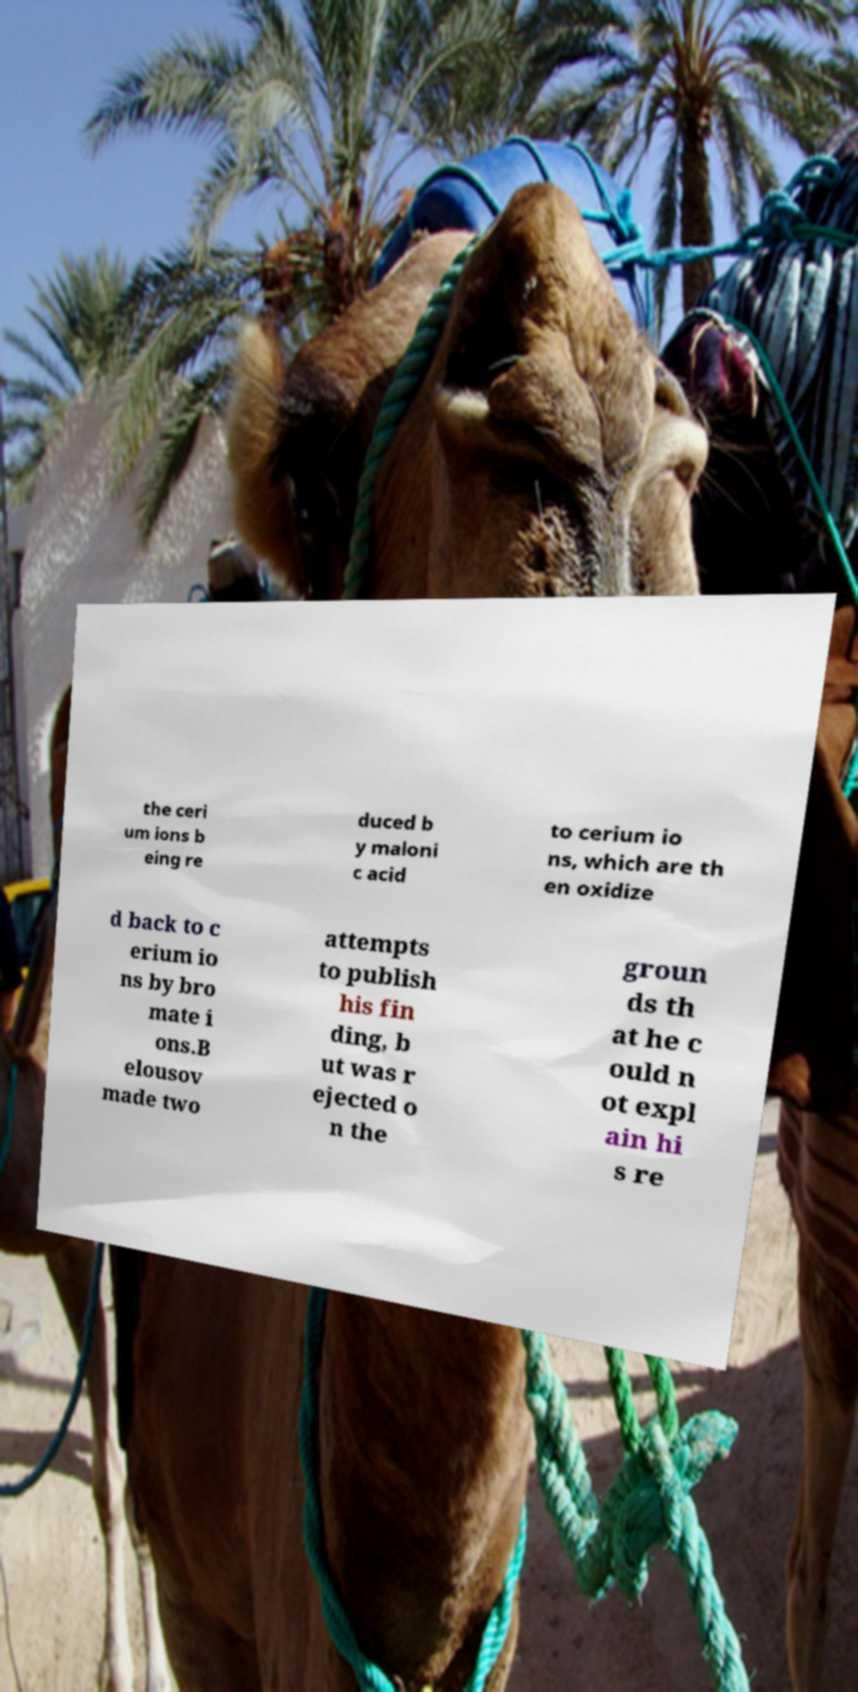Could you assist in decoding the text presented in this image and type it out clearly? the ceri um ions b eing re duced b y maloni c acid to cerium io ns, which are th en oxidize d back to c erium io ns by bro mate i ons.B elousov made two attempts to publish his fin ding, b ut was r ejected o n the groun ds th at he c ould n ot expl ain hi s re 